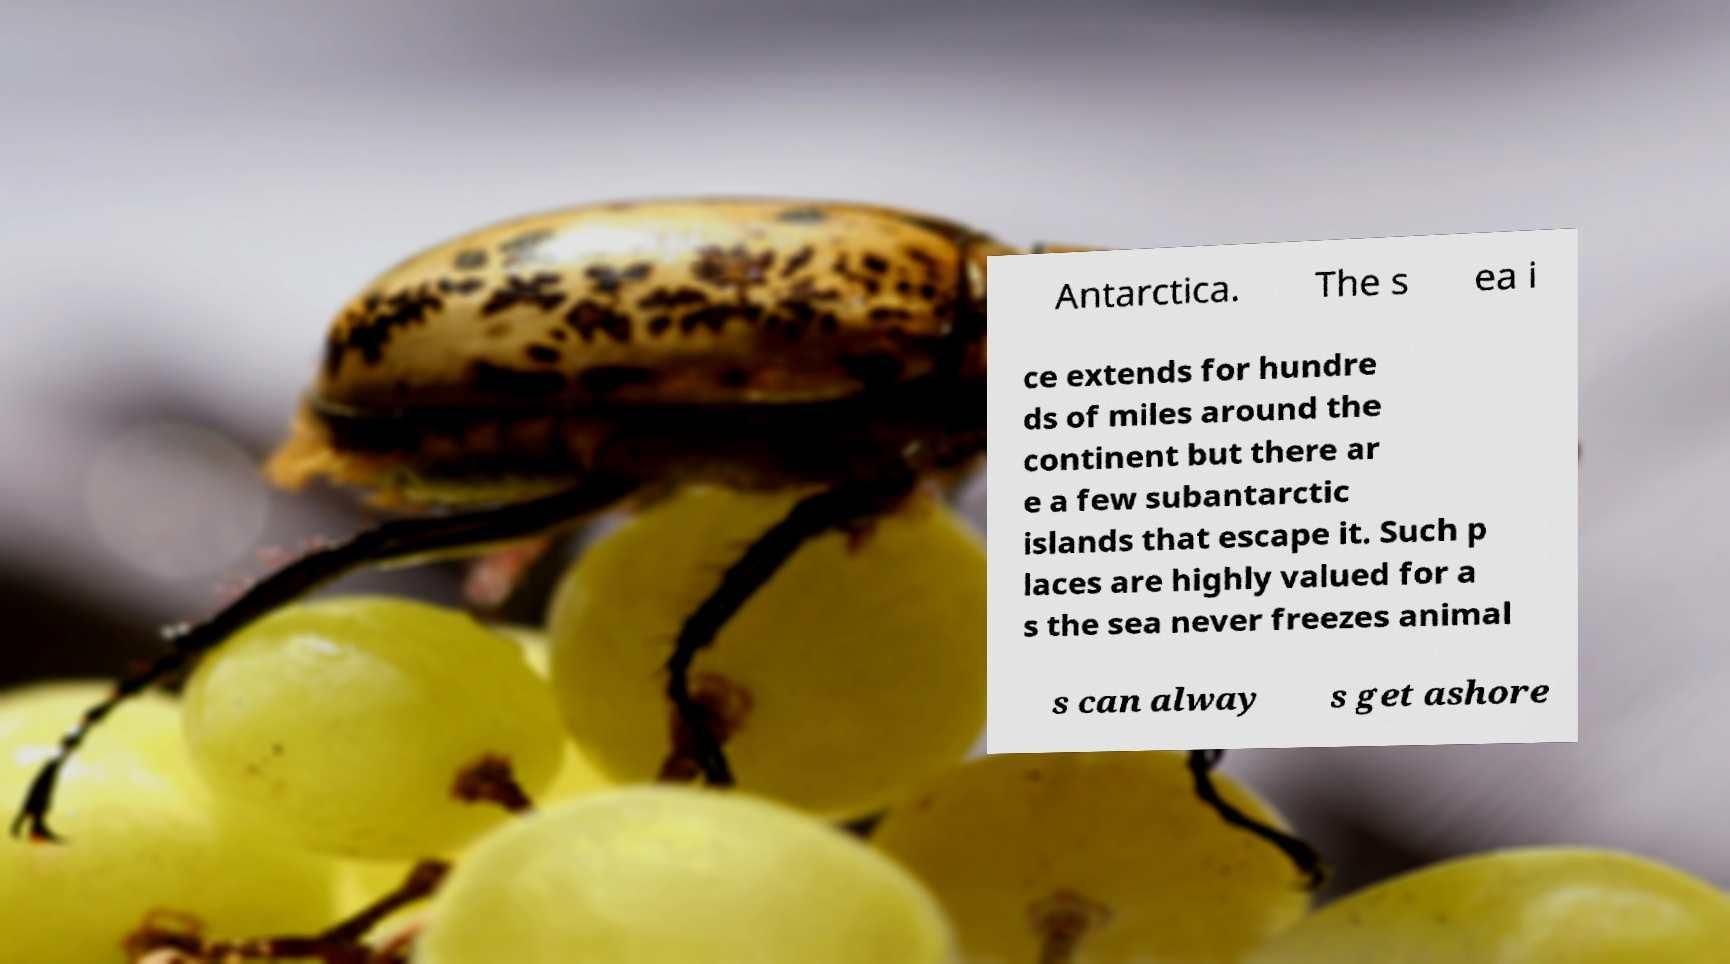Can you read and provide the text displayed in the image?This photo seems to have some interesting text. Can you extract and type it out for me? Antarctica. The s ea i ce extends for hundre ds of miles around the continent but there ar e a few subantarctic islands that escape it. Such p laces are highly valued for a s the sea never freezes animal s can alway s get ashore 